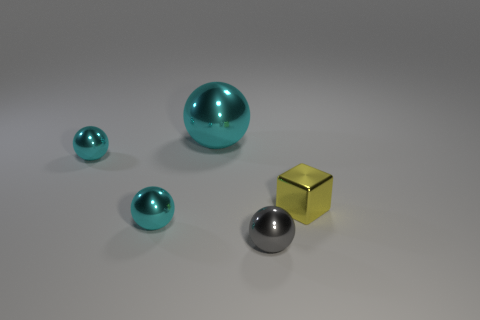Is there a red sphere made of the same material as the tiny yellow thing?
Your answer should be very brief. No. There is a gray ball that is the same size as the cube; what is its material?
Ensure brevity in your answer.  Metal. There is a shiny object that is right of the tiny ball in front of the small cyan object that is in front of the small metallic cube; what size is it?
Your response must be concise. Small. Are there any shiny objects to the right of the sphere on the right side of the large shiny thing?
Your response must be concise. Yes. There is a big cyan metallic object; is its shape the same as the gray object that is in front of the tiny yellow metal thing?
Provide a short and direct response. Yes. The small metal thing that is right of the tiny gray sphere is what color?
Give a very brief answer. Yellow. There is a metallic object that is on the right side of the small sphere that is right of the large cyan metal object; how big is it?
Make the answer very short. Small. There is a small cyan metal object behind the tiny cube; does it have the same shape as the tiny yellow thing?
Provide a succinct answer. No. There is a big cyan thing that is the same shape as the gray object; what material is it?
Your answer should be compact. Metal. What number of things are tiny shiny objects to the left of the big cyan object or metal things on the left side of the gray shiny thing?
Ensure brevity in your answer.  3. 